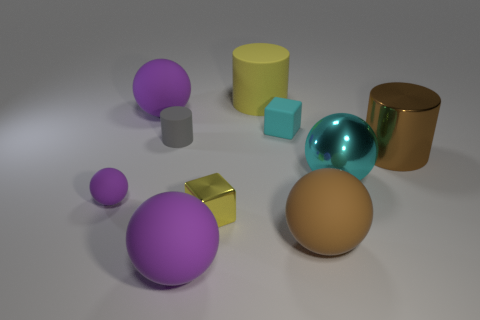What color is the metal block that is the same size as the gray rubber cylinder?
Offer a very short reply. Yellow. How many objects are either tiny cyan rubber cubes or big brown cylinders?
Offer a terse response. 2. There is a tiny purple object; are there any brown metal cylinders in front of it?
Provide a succinct answer. No. Is there a small brown cylinder that has the same material as the yellow block?
Offer a very short reply. No. There is a matte sphere that is the same color as the metal cylinder; what size is it?
Offer a terse response. Large. What number of cylinders are tiny cyan matte things or brown rubber things?
Your answer should be very brief. 0. Is the number of big spheres that are right of the yellow shiny object greater than the number of large cyan metallic objects behind the big yellow rubber object?
Give a very brief answer. Yes. How many large matte spheres are the same color as the small matte cylinder?
Give a very brief answer. 0. There is a brown object that is the same material as the large cyan thing; what is its size?
Your answer should be compact. Large. What number of things are cylinders that are on the left side of the big yellow rubber thing or small gray cubes?
Provide a succinct answer. 1. 